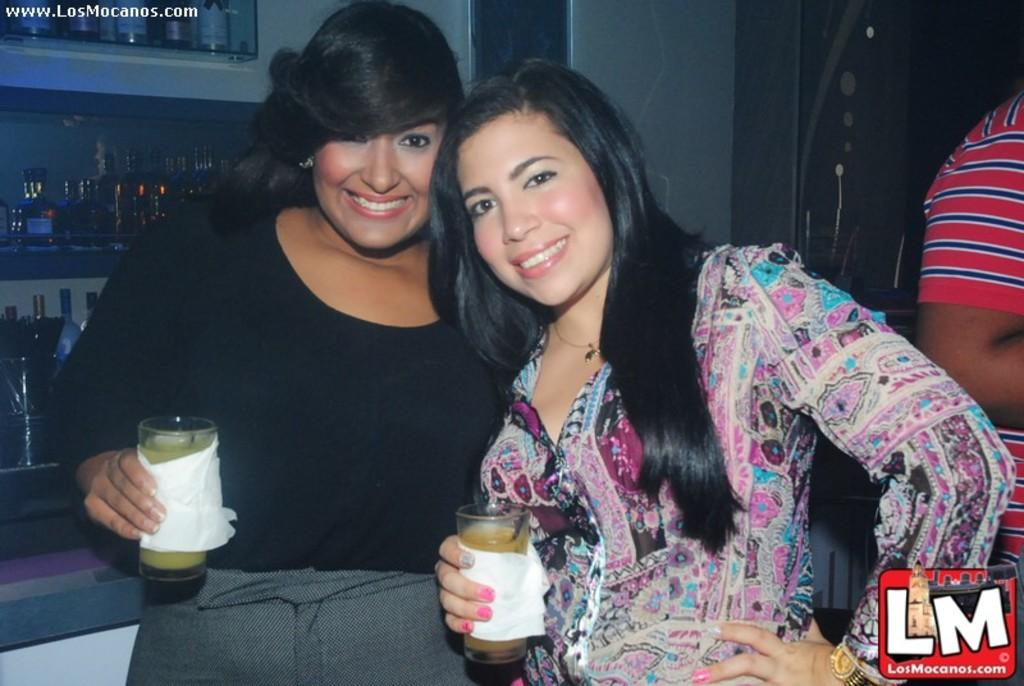How many people are in the image? There are two ladies in the image. What are the ladies holding in their hands? The ladies are holding glasses with tissue. What can be seen in the background of the image? There are many bottles on racks in the background of the image. Can you describe any imperfections or marks on the image? Yes, there are watermarks on the image. Where is the mother of the ladies in the image? There is no mention of a mother in the image, so we cannot determine her location. How many birds are in the flock visible in the image? There are no birds or flocks present in the image. 